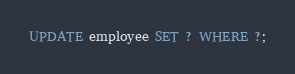Convert code to text. <code><loc_0><loc_0><loc_500><loc_500><_SQL_>UPDATE employee SET ? WHERE ?;</code> 